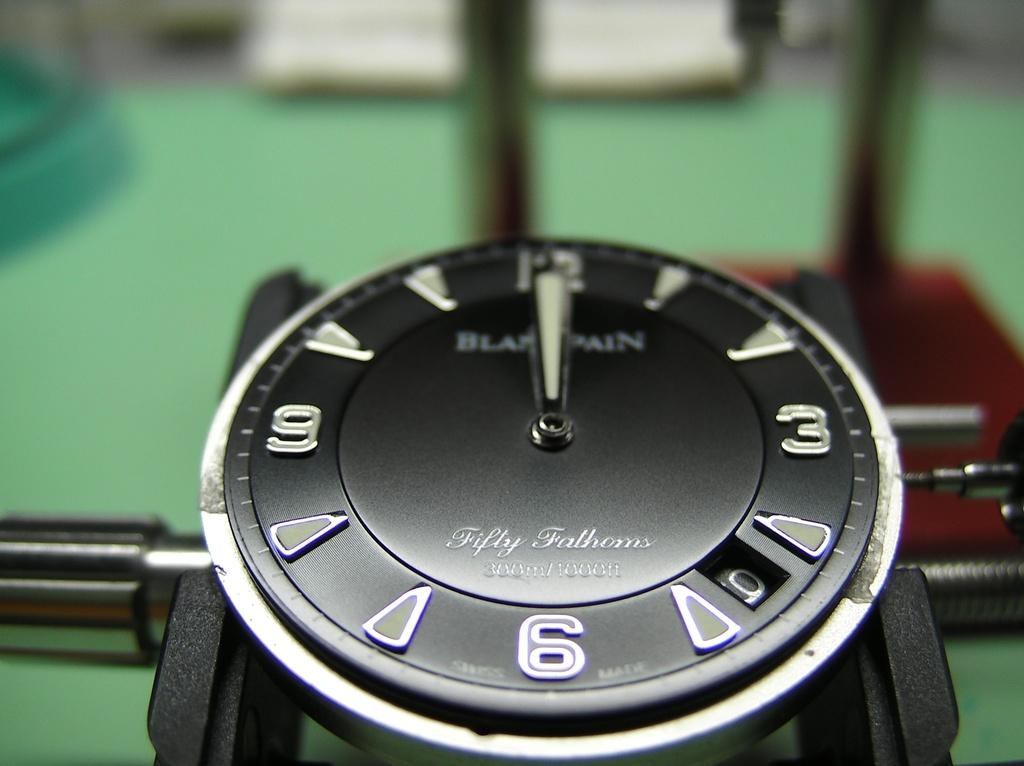What is the main object in the image? There is a clock dial in the image. Where is the clock dial located? The clock dial is placed on a machine. What type of pleasure can be seen being sorted by the machine in the image? There is no machine or pleasure present in the image; it only features a clock dial placed on a machine. 